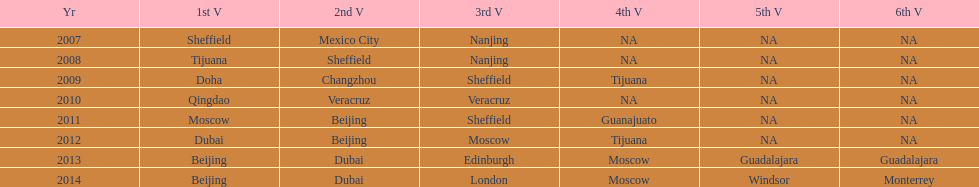How long, in years, has the this world series been occurring? 7 years. 